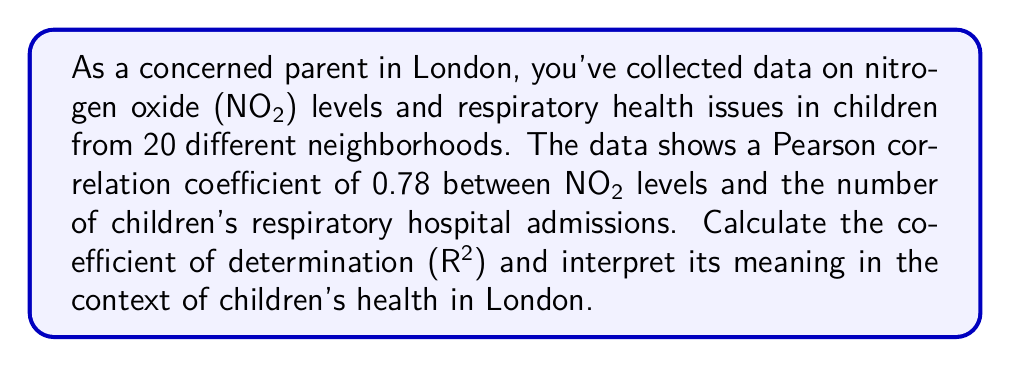Can you answer this question? To solve this problem, we need to follow these steps:

1. Understand the given information:
   - We have a Pearson correlation coefficient (r) of 0.78
   - We need to calculate the coefficient of determination (R²)

2. Calculate R²:
   The coefficient of determination is the square of the Pearson correlation coefficient.
   
   $$R^2 = r^2$$
   $$R^2 = (0.78)^2$$
   $$R^2 = 0.6084$$

3. Interpret the result:
   The coefficient of determination (R²) represents the proportion of the variance in the dependent variable (children's respiratory hospital admissions) that is predictable from the independent variable (NO₂ levels).

   In this case, R² = 0.6084, which means that approximately 60.84% of the variance in children's respiratory hospital admissions can be explained by the variation in NO₂ levels in London neighborhoods.

   To interpret this in the context of children's health in London:
   - About 60.84% of the differences in children's respiratory hospital admissions across London neighborhoods can be attributed to differences in NO₂ levels.
   - The remaining 39.16% of the variance is due to other factors not accounted for in this analysis.

   This suggests a strong relationship between NO₂ levels and children's respiratory health issues in London, which is concerning for parents and public health officials.
Answer: The coefficient of determination (R²) is 0.6084, indicating that approximately 60.84% of the variance in children's respiratory hospital admissions can be explained by NO₂ levels in London neighborhoods. 